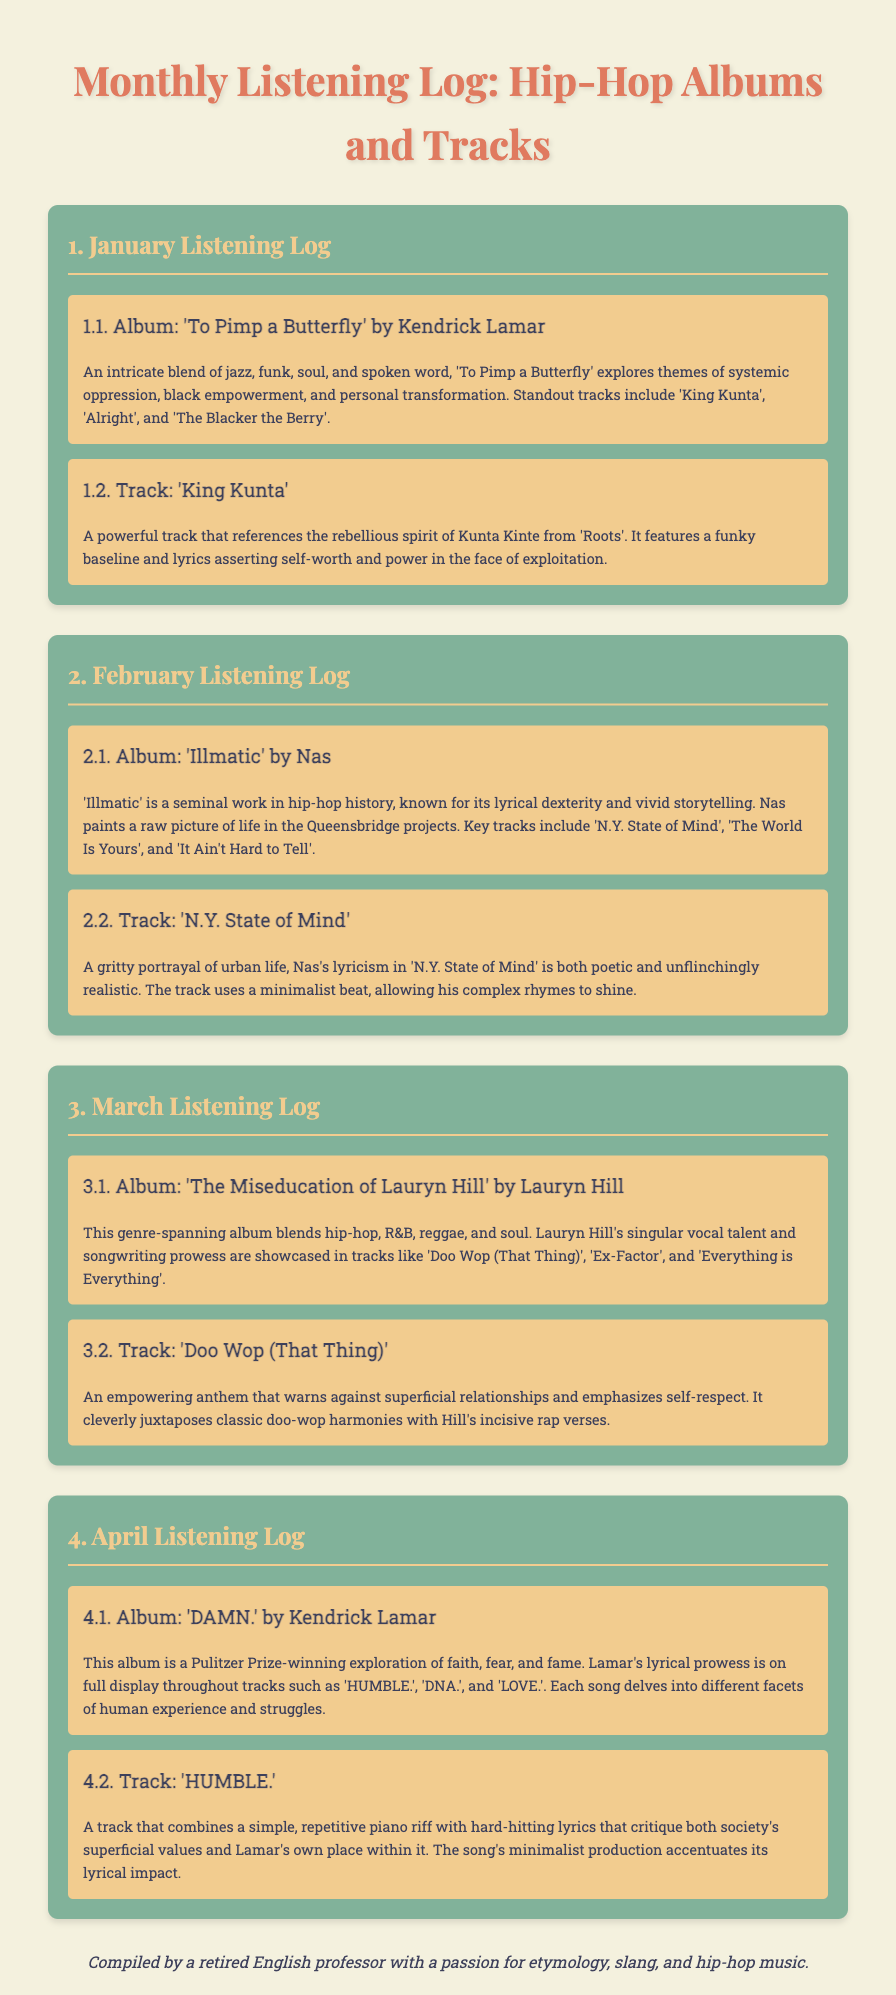What is the title of the first album mentioned? The title of the first album is the one listed under January, which is a detailed summary that explores various themes.
Answer: To Pimp a Butterfly Who is the artist of 'Illmatic'? The document specifies the artist associated with the album 'Illmatic', highlighting its impact on hip-hop.
Answer: Nas What is a standout track from 'DAMN.'? The document lists various tracks from the album 'DAMN.', including those that explore profound themes.
Answer: HUMBLE How many months are covered in the listening log? The summary includes specific sections for each month, providing insights into the albums and tracks listed.
Answer: Four Which month features 'The Miseducation of Lauryn Hill'? Each section is titled with the month it covers, making it clear when Lauryn Hill’s album is discussed.
Answer: March What genre does 'To Pimp a Butterfly' primarily blend? The document describes the first album as having a mixture of genres that contribute to its themes.
Answer: Jazz, funk, soul, and spoken word What is the main theme reviewed in 'N.Y. State of Mind'? Each track summary details significant themes reflected in the artist's work and the challenges depicted.
Answer: Urban life What musical element is prominent in 'Doo Wop (That Thing)'? The description of the track indicates how its musical features relate to the messages conveyed in the lyrics.
Answer: Doo-wop harmonies 